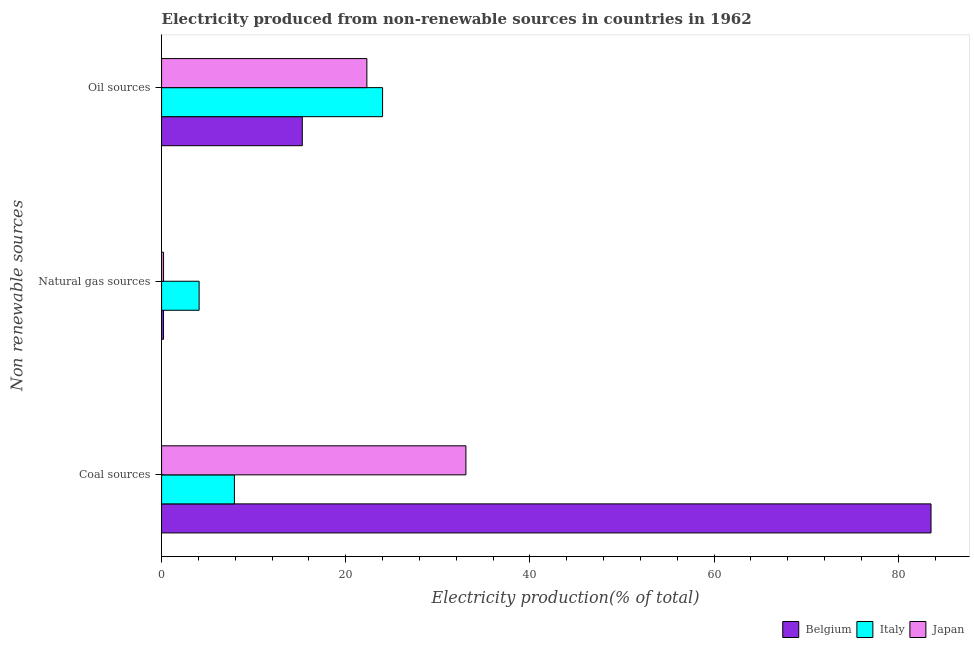Are the number of bars per tick equal to the number of legend labels?
Make the answer very short. Yes. Are the number of bars on each tick of the Y-axis equal?
Provide a short and direct response. Yes. How many bars are there on the 3rd tick from the top?
Give a very brief answer. 3. How many bars are there on the 3rd tick from the bottom?
Your answer should be compact. 3. What is the label of the 3rd group of bars from the top?
Your response must be concise. Coal sources. What is the percentage of electricity produced by oil sources in Japan?
Provide a succinct answer. 22.29. Across all countries, what is the maximum percentage of electricity produced by oil sources?
Make the answer very short. 24. Across all countries, what is the minimum percentage of electricity produced by coal?
Keep it short and to the point. 7.91. What is the total percentage of electricity produced by natural gas in the graph?
Make the answer very short. 4.5. What is the difference between the percentage of electricity produced by oil sources in Italy and that in Japan?
Offer a terse response. 1.71. What is the difference between the percentage of electricity produced by oil sources in Japan and the percentage of electricity produced by coal in Italy?
Offer a terse response. 14.38. What is the average percentage of electricity produced by natural gas per country?
Keep it short and to the point. 1.5. What is the difference between the percentage of electricity produced by natural gas and percentage of electricity produced by oil sources in Japan?
Keep it short and to the point. -22.08. In how many countries, is the percentage of electricity produced by natural gas greater than 12 %?
Make the answer very short. 0. What is the ratio of the percentage of electricity produced by coal in Belgium to that in Japan?
Make the answer very short. 2.53. What is the difference between the highest and the second highest percentage of electricity produced by natural gas?
Your response must be concise. 3.86. What is the difference between the highest and the lowest percentage of electricity produced by natural gas?
Offer a terse response. 3.87. Is the sum of the percentage of electricity produced by coal in Japan and Italy greater than the maximum percentage of electricity produced by natural gas across all countries?
Your response must be concise. Yes. What does the 3rd bar from the top in Natural gas sources represents?
Offer a terse response. Belgium. What does the 3rd bar from the bottom in Natural gas sources represents?
Offer a terse response. Japan. Is it the case that in every country, the sum of the percentage of electricity produced by coal and percentage of electricity produced by natural gas is greater than the percentage of electricity produced by oil sources?
Offer a terse response. No. How many bars are there?
Your answer should be very brief. 9. Are all the bars in the graph horizontal?
Offer a very short reply. Yes. How many countries are there in the graph?
Provide a succinct answer. 3. What is the difference between two consecutive major ticks on the X-axis?
Offer a very short reply. 20. Where does the legend appear in the graph?
Ensure brevity in your answer.  Bottom right. How many legend labels are there?
Your answer should be compact. 3. What is the title of the graph?
Offer a very short reply. Electricity produced from non-renewable sources in countries in 1962. Does "Malawi" appear as one of the legend labels in the graph?
Make the answer very short. No. What is the label or title of the X-axis?
Your answer should be compact. Electricity production(% of total). What is the label or title of the Y-axis?
Provide a succinct answer. Non renewable sources. What is the Electricity production(% of total) in Belgium in Coal sources?
Your answer should be compact. 83.56. What is the Electricity production(% of total) of Italy in Coal sources?
Make the answer very short. 7.91. What is the Electricity production(% of total) of Japan in Coal sources?
Your response must be concise. 33.05. What is the Electricity production(% of total) in Belgium in Natural gas sources?
Your response must be concise. 0.21. What is the Electricity production(% of total) in Italy in Natural gas sources?
Ensure brevity in your answer.  4.08. What is the Electricity production(% of total) in Japan in Natural gas sources?
Give a very brief answer. 0.21. What is the Electricity production(% of total) in Belgium in Oil sources?
Your response must be concise. 15.28. What is the Electricity production(% of total) of Italy in Oil sources?
Provide a short and direct response. 24. What is the Electricity production(% of total) of Japan in Oil sources?
Your answer should be compact. 22.29. Across all Non renewable sources, what is the maximum Electricity production(% of total) of Belgium?
Make the answer very short. 83.56. Across all Non renewable sources, what is the maximum Electricity production(% of total) in Italy?
Ensure brevity in your answer.  24. Across all Non renewable sources, what is the maximum Electricity production(% of total) of Japan?
Your response must be concise. 33.05. Across all Non renewable sources, what is the minimum Electricity production(% of total) in Belgium?
Make the answer very short. 0.21. Across all Non renewable sources, what is the minimum Electricity production(% of total) in Italy?
Your answer should be compact. 4.08. Across all Non renewable sources, what is the minimum Electricity production(% of total) of Japan?
Your answer should be compact. 0.21. What is the total Electricity production(% of total) in Belgium in the graph?
Your response must be concise. 99.05. What is the total Electricity production(% of total) of Italy in the graph?
Ensure brevity in your answer.  35.99. What is the total Electricity production(% of total) in Japan in the graph?
Offer a terse response. 55.56. What is the difference between the Electricity production(% of total) in Belgium in Coal sources and that in Natural gas sources?
Give a very brief answer. 83.35. What is the difference between the Electricity production(% of total) in Italy in Coal sources and that in Natural gas sources?
Ensure brevity in your answer.  3.83. What is the difference between the Electricity production(% of total) of Japan in Coal sources and that in Natural gas sources?
Ensure brevity in your answer.  32.83. What is the difference between the Electricity production(% of total) in Belgium in Coal sources and that in Oil sources?
Offer a very short reply. 68.28. What is the difference between the Electricity production(% of total) in Italy in Coal sources and that in Oil sources?
Your answer should be very brief. -16.09. What is the difference between the Electricity production(% of total) in Japan in Coal sources and that in Oil sources?
Your answer should be very brief. 10.76. What is the difference between the Electricity production(% of total) in Belgium in Natural gas sources and that in Oil sources?
Your answer should be very brief. -15.07. What is the difference between the Electricity production(% of total) of Italy in Natural gas sources and that in Oil sources?
Provide a short and direct response. -19.92. What is the difference between the Electricity production(% of total) in Japan in Natural gas sources and that in Oil sources?
Offer a terse response. -22.08. What is the difference between the Electricity production(% of total) of Belgium in Coal sources and the Electricity production(% of total) of Italy in Natural gas sources?
Make the answer very short. 79.48. What is the difference between the Electricity production(% of total) of Belgium in Coal sources and the Electricity production(% of total) of Japan in Natural gas sources?
Provide a short and direct response. 83.34. What is the difference between the Electricity production(% of total) of Italy in Coal sources and the Electricity production(% of total) of Japan in Natural gas sources?
Make the answer very short. 7.7. What is the difference between the Electricity production(% of total) of Belgium in Coal sources and the Electricity production(% of total) of Italy in Oil sources?
Your response must be concise. 59.56. What is the difference between the Electricity production(% of total) in Belgium in Coal sources and the Electricity production(% of total) in Japan in Oil sources?
Make the answer very short. 61.26. What is the difference between the Electricity production(% of total) in Italy in Coal sources and the Electricity production(% of total) in Japan in Oil sources?
Provide a succinct answer. -14.38. What is the difference between the Electricity production(% of total) in Belgium in Natural gas sources and the Electricity production(% of total) in Italy in Oil sources?
Offer a terse response. -23.79. What is the difference between the Electricity production(% of total) of Belgium in Natural gas sources and the Electricity production(% of total) of Japan in Oil sources?
Your answer should be very brief. -22.08. What is the difference between the Electricity production(% of total) in Italy in Natural gas sources and the Electricity production(% of total) in Japan in Oil sources?
Offer a very short reply. -18.21. What is the average Electricity production(% of total) in Belgium per Non renewable sources?
Provide a short and direct response. 33.02. What is the average Electricity production(% of total) of Italy per Non renewable sources?
Your answer should be compact. 12. What is the average Electricity production(% of total) in Japan per Non renewable sources?
Provide a short and direct response. 18.52. What is the difference between the Electricity production(% of total) in Belgium and Electricity production(% of total) in Italy in Coal sources?
Give a very brief answer. 75.65. What is the difference between the Electricity production(% of total) in Belgium and Electricity production(% of total) in Japan in Coal sources?
Make the answer very short. 50.51. What is the difference between the Electricity production(% of total) of Italy and Electricity production(% of total) of Japan in Coal sources?
Your response must be concise. -25.14. What is the difference between the Electricity production(% of total) in Belgium and Electricity production(% of total) in Italy in Natural gas sources?
Your answer should be compact. -3.87. What is the difference between the Electricity production(% of total) in Belgium and Electricity production(% of total) in Japan in Natural gas sources?
Your answer should be compact. -0. What is the difference between the Electricity production(% of total) in Italy and Electricity production(% of total) in Japan in Natural gas sources?
Your response must be concise. 3.86. What is the difference between the Electricity production(% of total) in Belgium and Electricity production(% of total) in Italy in Oil sources?
Give a very brief answer. -8.72. What is the difference between the Electricity production(% of total) in Belgium and Electricity production(% of total) in Japan in Oil sources?
Keep it short and to the point. -7.01. What is the difference between the Electricity production(% of total) of Italy and Electricity production(% of total) of Japan in Oil sources?
Keep it short and to the point. 1.71. What is the ratio of the Electricity production(% of total) in Belgium in Coal sources to that in Natural gas sources?
Your response must be concise. 396.22. What is the ratio of the Electricity production(% of total) of Italy in Coal sources to that in Natural gas sources?
Your answer should be compact. 1.94. What is the ratio of the Electricity production(% of total) in Japan in Coal sources to that in Natural gas sources?
Give a very brief answer. 154.67. What is the ratio of the Electricity production(% of total) in Belgium in Coal sources to that in Oil sources?
Ensure brevity in your answer.  5.47. What is the ratio of the Electricity production(% of total) of Italy in Coal sources to that in Oil sources?
Offer a very short reply. 0.33. What is the ratio of the Electricity production(% of total) in Japan in Coal sources to that in Oil sources?
Keep it short and to the point. 1.48. What is the ratio of the Electricity production(% of total) of Belgium in Natural gas sources to that in Oil sources?
Keep it short and to the point. 0.01. What is the ratio of the Electricity production(% of total) of Italy in Natural gas sources to that in Oil sources?
Provide a succinct answer. 0.17. What is the ratio of the Electricity production(% of total) of Japan in Natural gas sources to that in Oil sources?
Ensure brevity in your answer.  0.01. What is the difference between the highest and the second highest Electricity production(% of total) in Belgium?
Give a very brief answer. 68.28. What is the difference between the highest and the second highest Electricity production(% of total) in Italy?
Offer a terse response. 16.09. What is the difference between the highest and the second highest Electricity production(% of total) in Japan?
Your answer should be very brief. 10.76. What is the difference between the highest and the lowest Electricity production(% of total) in Belgium?
Your answer should be compact. 83.35. What is the difference between the highest and the lowest Electricity production(% of total) of Italy?
Your answer should be compact. 19.92. What is the difference between the highest and the lowest Electricity production(% of total) of Japan?
Your answer should be very brief. 32.83. 